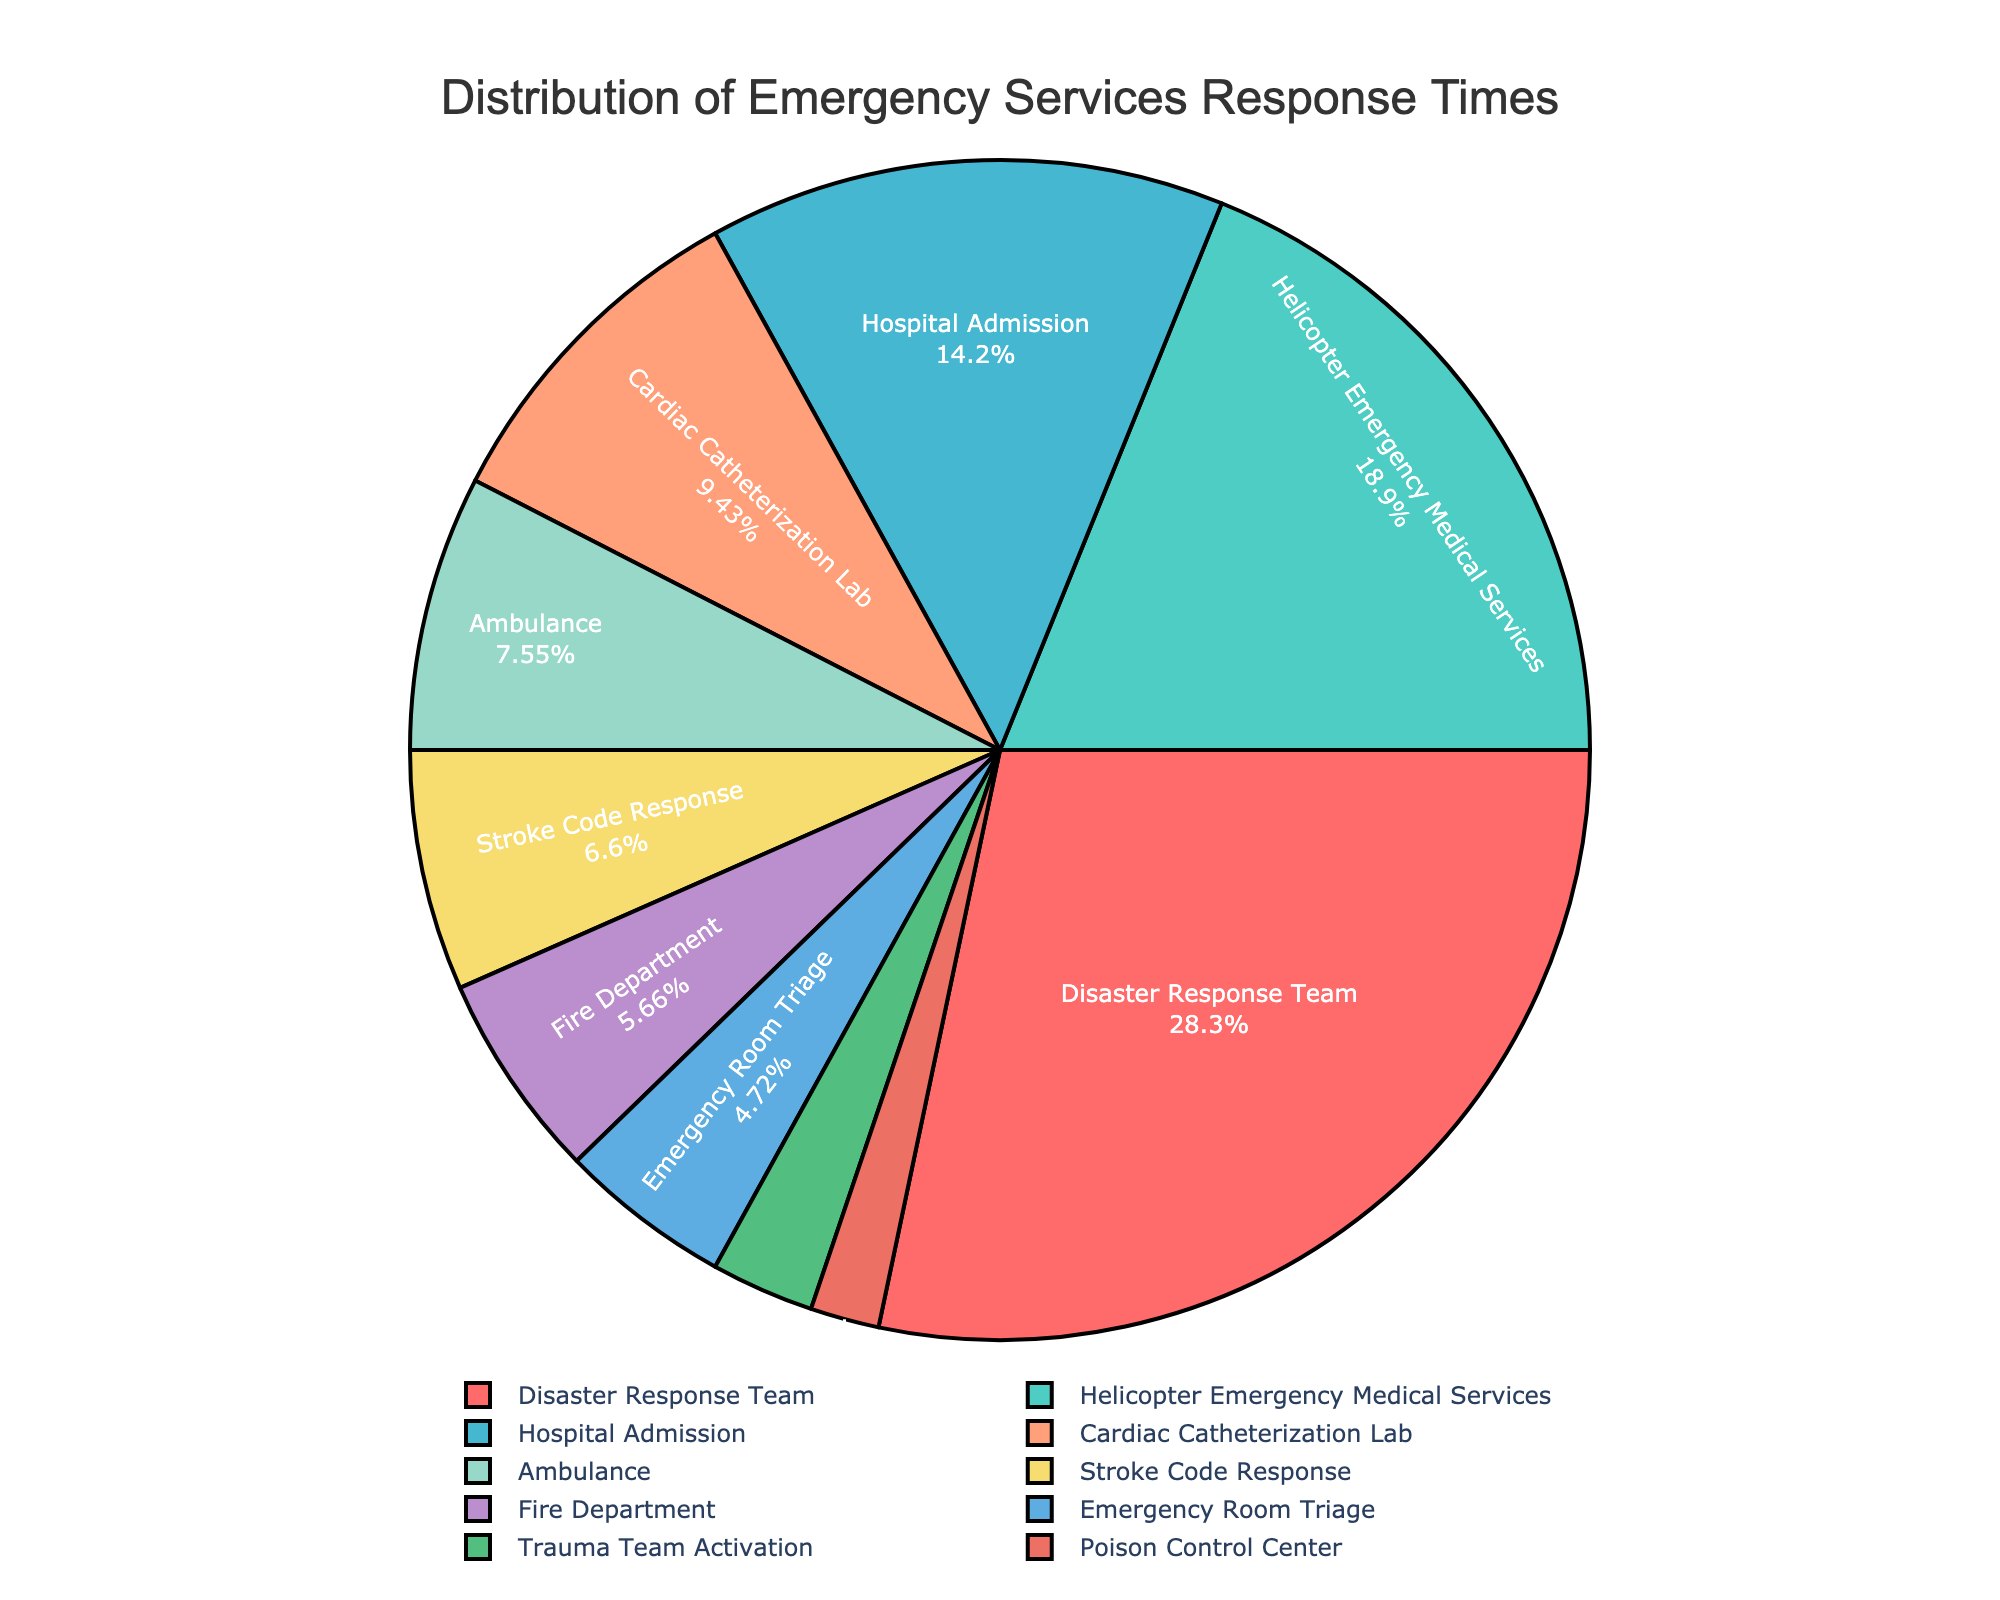Which emergency service has the highest average response time? By examining the pie chart, identify the segment with the largest percentage, as this corresponds to the highest average response time.
Answer: Disaster Response Team Which emergency service has the lowest average response time? Look for the segment with the smallest percentage on the pie chart, indicating the lowest average response time.
Answer: Poison Control Center What is the difference in average response time between the Trauma Team Activation and the Hospital Admission services? Find the percentages for Trauma Team Activation and Hospital Admission and calculate the difference between these values. Trauma Team Activation is 3% and Hospital Admission is 15%, thus the difference is 15% - 3% = 12%.
Answer: 12 minutes Which emergency service has a response time closest to the average of all services combined? First, calculate the overall average response time by summing all times and dividing by the number of services. Then find the service with a response time closest to this value. The sum is 106, and there are 10 services, so the average is 106/10 = 10.6. The service closest to this average is the Cardiac Catheterization Lab with 10 minutes.
Answer: Cardiac Catheterization Lab How much higher is the average response time for Helicopter Emergency Medical Services compared to Stroke Code Response? Identify both segments' values: Helicopter Emergency Medical Services is 20 minutes and Stroke Code Response is 7 minutes. Subtract the lower value from the higher one: 20 - 7 = 13 minutes.
Answer: 13 minutes Which three services have the quickest average response times? Identify the three smallest percentages on the pie chart, corresponding to the smallest average response times. These are Poison Control Center (2 minutes), Trauma Team Activation (3 minutes), and Emergency Room Triage (5 minutes).
Answer: Poison Control Center, Trauma Team Activation, Emergency Room Triage Which service accounts for more response time: Ambulance or Cardiac Catheterization Lab? Compare the response times of Ambulance (8 minutes) and Cardiac Catheterization Lab (10 minutes). The Cardiac Catheterization Lab has the higher time.
Answer: Cardiac Catheterization Lab What percentage of the total response time is attributed to Disaster Response Team? The percentage of the total response time for each service is shown on the pie chart. Find the percentage for the Disaster Response Team segment. This value is 30%.
Answer: 30% If Poison Control Center and Hospital Admission services were combined, what would their total average response time be? Add the average response times for Poison Control Center (2 minutes) and Hospital Admission (15 minutes) to get the sum: 2 + 15 = 17 minutes.
Answer: 17 minutes Arrange the services in descending order of their average response times. List all the services based on the values shown in the pie chart from highest to lowest average response time: Disaster Response Team (30%), Helicopter Emergency Medical Services (20%), Hospital Admission (15%), Cardiac Catheterization Lab (10%), Ambulance (8%), Stroke Code Response (7%), Fire Department (6%), Emergency Room Triage (5%), Trauma Team Activation (3%), Poison Control Center (2%).
Answer: Disaster Response Team, Helicopter Emergency Medical Services, Hospital Admission, Cardiac Catheterization Lab, Ambulance, Stroke Code Response, Fire Department, Emergency Room Triage, Trauma Team Activation, Poison Control Center 